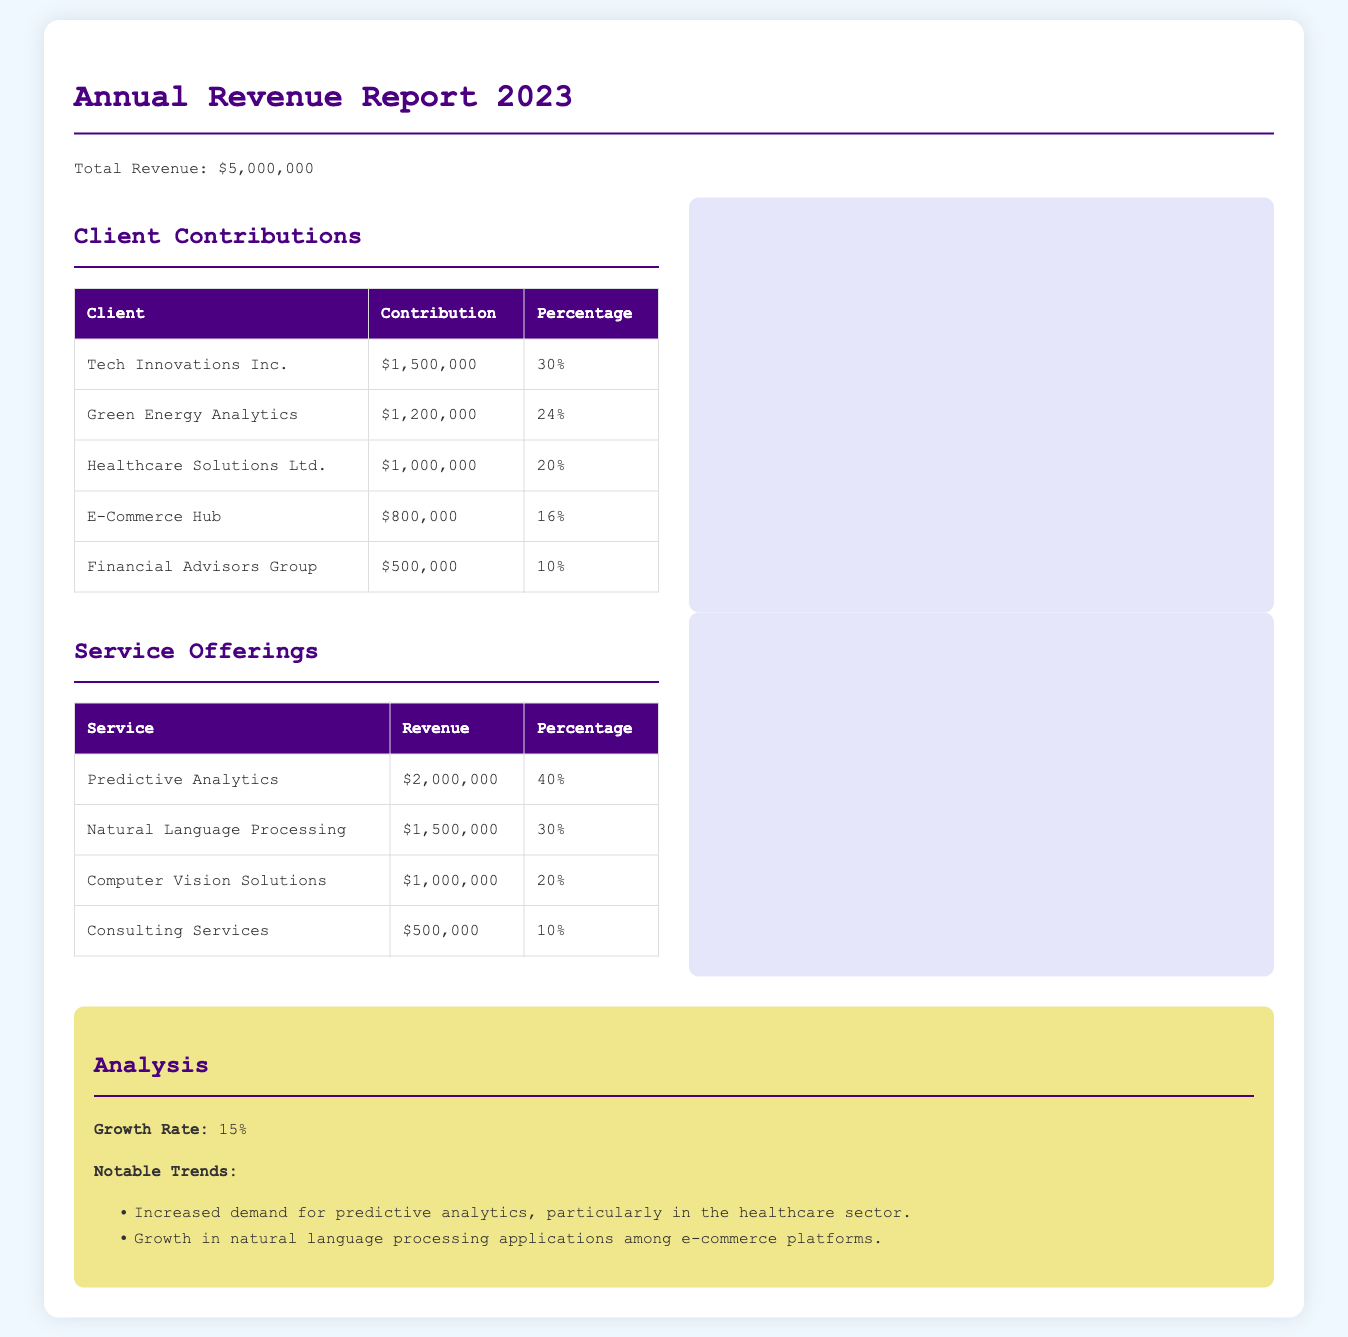What is the total revenue? The total revenue is stated in the document as $5,000,000.
Answer: $5,000,000 Which client contributed the most? The client with the highest contribution listed in the document is Tech Innovations Inc. with $1,500,000.
Answer: Tech Innovations Inc What percentage of revenue does Natural Language Processing account for? The document states that Natural Language Processing earns 30% of the total revenue.
Answer: 30% What was the growth rate mentioned in the analysis? The analysis section of the document specifies a growth rate of 15%.
Answer: 15% How much did Financial Advisors Group contribute? The table in the document shows that Financial Advisors Group contributed $500,000.
Answer: $500,000 What is the revenue from Consulting Services? Consulting Services generated revenue of $500,000 as per the service offerings table.
Answer: $500,000 What is the percentage contribution of Healthcare Solutions Ltd.? The contribution percentage of Healthcare Solutions Ltd. is noted as 20% in the document.
Answer: 20% Which service offering generated the most revenue? The service offering with the highest revenue is Predictive Analytics, totaling $2,000,000.
Answer: Predictive Analytics What notable trend is mentioned in the analysis? The analysis highlights increased demand for predictive analytics, especially in healthcare.
Answer: Increased demand for predictive analytics 